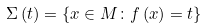Convert formula to latex. <formula><loc_0><loc_0><loc_500><loc_500>\Sigma \left ( t \right ) = \left \{ x \in M \colon f \left ( x \right ) = t \right \}</formula> 